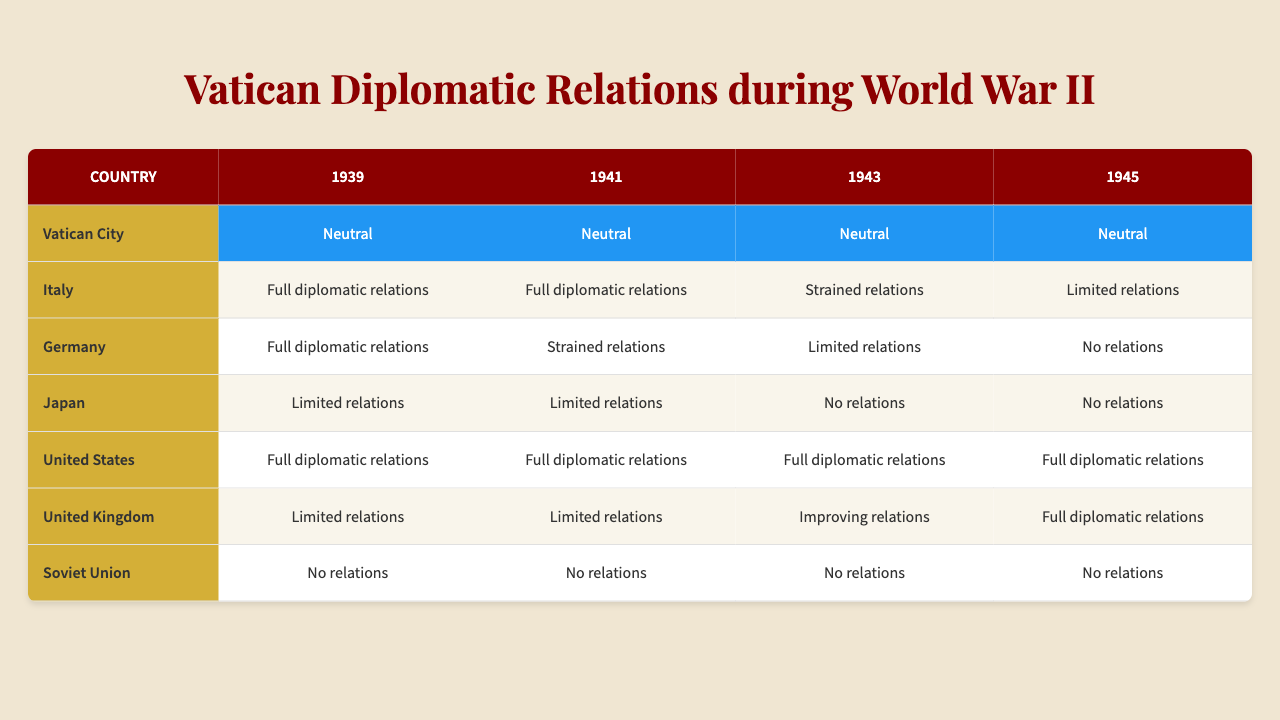What were the diplomatic relations of the Vatican with Germany in 1943? The table shows that the Vatican had "Limited relations" with Germany in 1943.
Answer: Limited relations Did the Vatican maintain neutral relations throughout the entire war? The table indicates that the Vatican remained "Neutral" in all years listed (1939, 1941, 1943, 1945), showing consistent neutrality throughout the war.
Answer: Yes Which country had the most consistent diplomatic relations with the Vatican during the war years? By analyzing the table, the United States had "Full diplomatic relations" in all years (1939, 1941, 1943, 1945), which is consistent across the board.
Answer: United States In what year did Italy's diplomatic relations with the Vatican become strained? According to the table, Italy's relations with the Vatican became "Strained" in 1943.
Answer: 1943 How many countries had "No relations" with the Vatican by 1945? From the table, both Japan and the Soviet Union had "No relations" with the Vatican in 1945, making a total of 2 countries.
Answer: 2 Is it true that Japan had "Full diplomatic relations" with the Vatican in 1941? The table displays that Japan had "Limited relations" in 1941, hence the claim is false.
Answer: No What was the change in the Vatican's relations with the United Kingdom from 1943 to 1945? The table reflects that relations improved from "Improving relations" in 1943 to "Full diplomatic relations" in 1945.
Answer: Improved What were the differences in the Vatican's relations with Japan between 1939 and 1943? In 1939, Japan had "Limited relations," which changed to "No relations" by 1943, indicating a deterioration in diplomatic ties.
Answer: Deteriorated How did the diplomatic relations with the Soviet Union change from 1939 to 1945? The table reveals that the Soviet Union had "No relations" in both 1939 and 1945, showing no change in diplomatic status.
Answer: No change What was the overall trend of Vatican relations with Axis powers during WWII? The data shows that relations with Axis powers (Italy, Germany, Japan) shifted from "Full" or "Limited" in the early years to "Strained" or "No relations" by the end of the war, indicating a negative trend.
Answer: Negative trend 